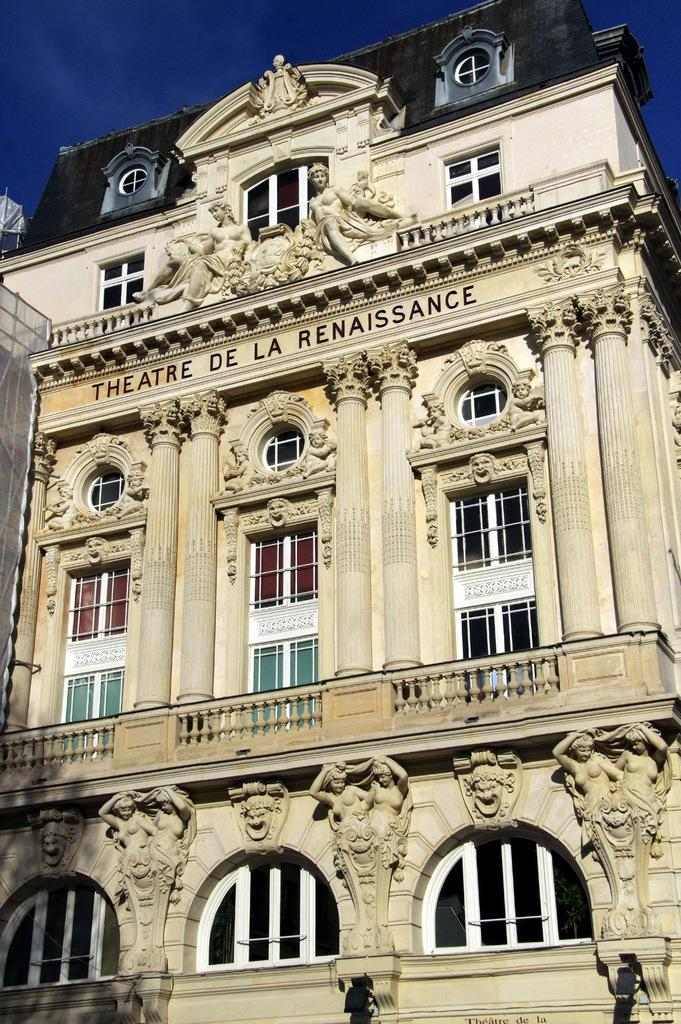What type of structure is in the image? There is a building in the image. What features can be seen on the building? The building has windows and sculptures. What can be seen behind the building in the image? The sky is visible behind the building. Can you tell me how many strangers are playing an industry-related game in the image? There are no strangers or any game being played in the image; it features a building with windows and sculptures, and the sky is visible behind it. 